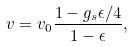<formula> <loc_0><loc_0><loc_500><loc_500>v = v _ { 0 } { \frac { 1 - g _ { s } \epsilon / 4 } { 1 - \epsilon } } ,</formula> 